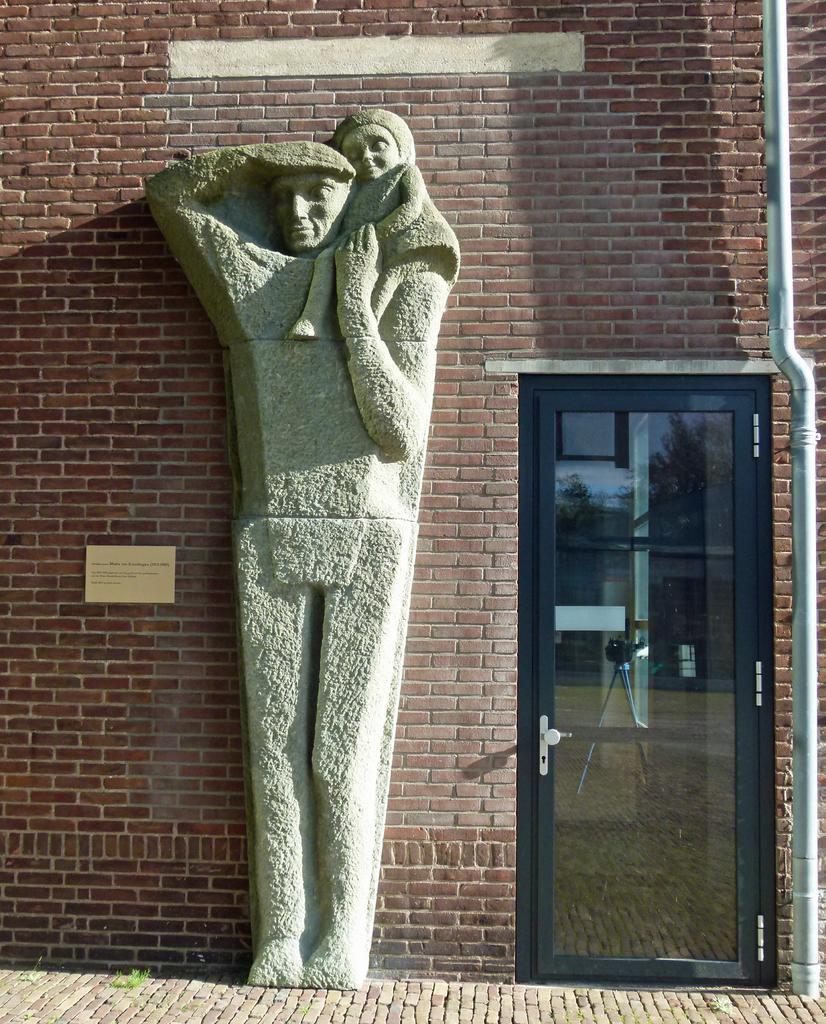In one or two sentences, can you explain what this image depicts? In this image we can see the sculpture on the brick wall. And we can see the door. And we can see the pipeline. 